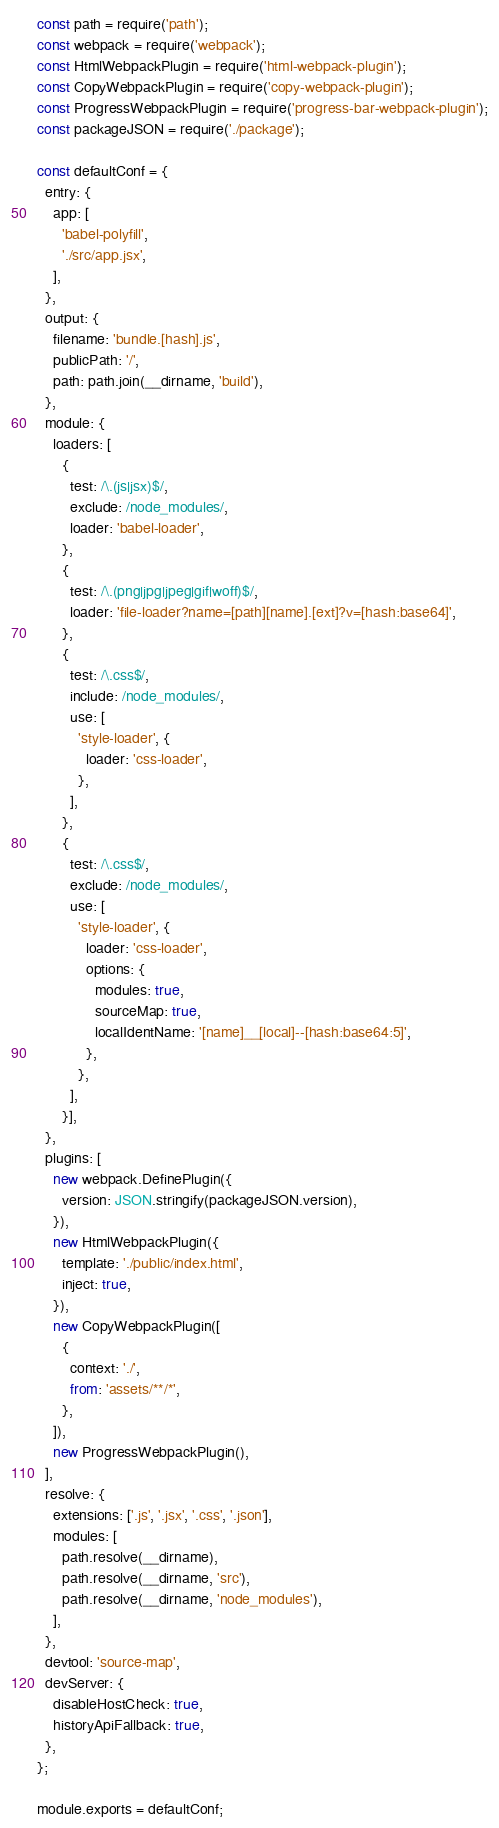Convert code to text. <code><loc_0><loc_0><loc_500><loc_500><_JavaScript_>const path = require('path');
const webpack = require('webpack');
const HtmlWebpackPlugin = require('html-webpack-plugin');
const CopyWebpackPlugin = require('copy-webpack-plugin');
const ProgressWebpackPlugin = require('progress-bar-webpack-plugin');
const packageJSON = require('./package');

const defaultConf = {
  entry: {
    app: [
      'babel-polyfill',
      './src/app.jsx',
    ],
  },
  output: {
    filename: 'bundle.[hash].js',
    publicPath: '/',
    path: path.join(__dirname, 'build'),
  },
  module: {
    loaders: [
      {
        test: /\.(js|jsx)$/,
        exclude: /node_modules/,
        loader: 'babel-loader',
      },
      {
        test: /\.(png|jpg|jpeg|gif|woff)$/,
        loader: 'file-loader?name=[path][name].[ext]?v=[hash:base64]',
      },
      {
        test: /\.css$/,
        include: /node_modules/,
        use: [
          'style-loader', {
            loader: 'css-loader',
          },
        ],
      },
      {
        test: /\.css$/,
        exclude: /node_modules/,
        use: [
          'style-loader', {
            loader: 'css-loader',
            options: {
              modules: true,
              sourceMap: true,
              localIdentName: '[name]__[local]--[hash:base64:5]',
            },
          },
        ],
      }],
  },
  plugins: [
    new webpack.DefinePlugin({
      version: JSON.stringify(packageJSON.version),
    }),
    new HtmlWebpackPlugin({
      template: './public/index.html',
      inject: true,
    }),
    new CopyWebpackPlugin([
      {
        context: './',
        from: 'assets/**/*',
      },
    ]),
    new ProgressWebpackPlugin(),
  ],
  resolve: {
    extensions: ['.js', '.jsx', '.css', '.json'],
    modules: [
      path.resolve(__dirname),
      path.resolve(__dirname, 'src'),
      path.resolve(__dirname, 'node_modules'),
    ],
  },
  devtool: 'source-map',
  devServer: {
    disableHostCheck: true,
    historyApiFallback: true,
  },
};

module.exports = defaultConf;
</code> 